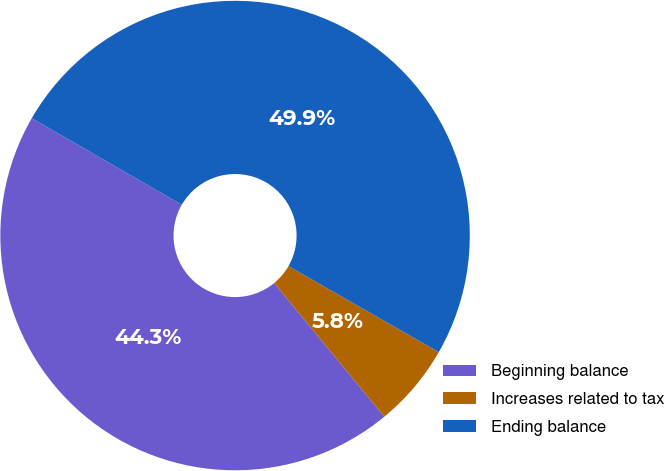<chart> <loc_0><loc_0><loc_500><loc_500><pie_chart><fcel>Beginning balance<fcel>Increases related to tax<fcel>Ending balance<nl><fcel>44.3%<fcel>5.76%<fcel>49.94%<nl></chart> 